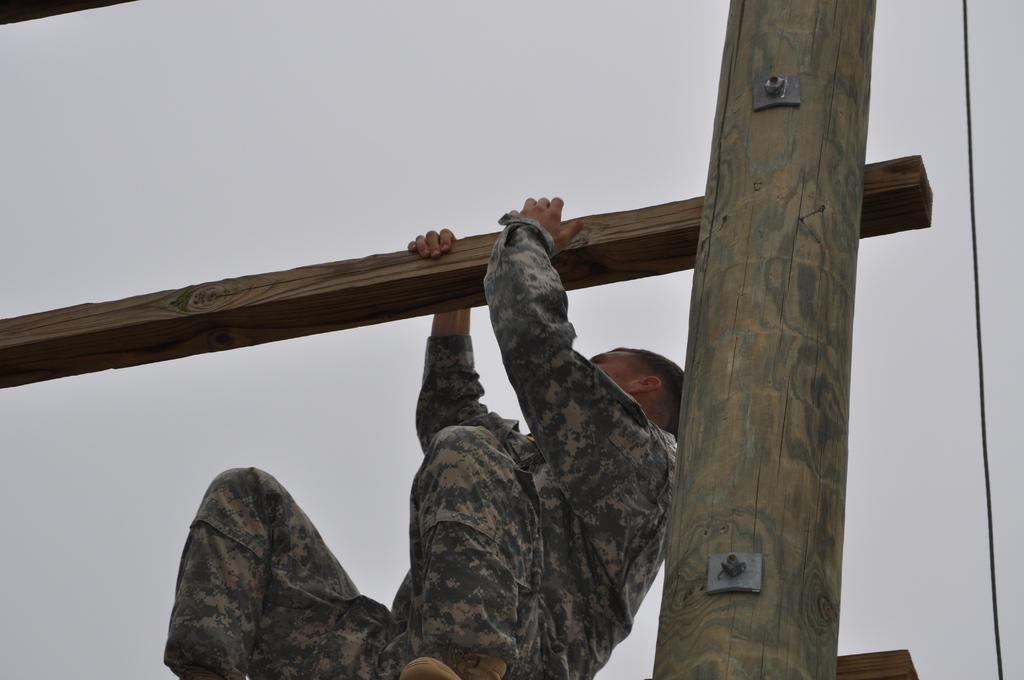What is the main subject of the image? There is a person in the image. What is the person holding in the image? The person is holding a wooden log. How is the person positioned in the image? The person is in a squat position. What is the person standing or sitting on in the image? The person is on another wooden log. How are the wooden logs connected or supported in the image? The wooden logs are fixed to a wooden block. How does the person fold the wooden log in the image? The person is not folding the wooden log in the image; they are simply holding it. 